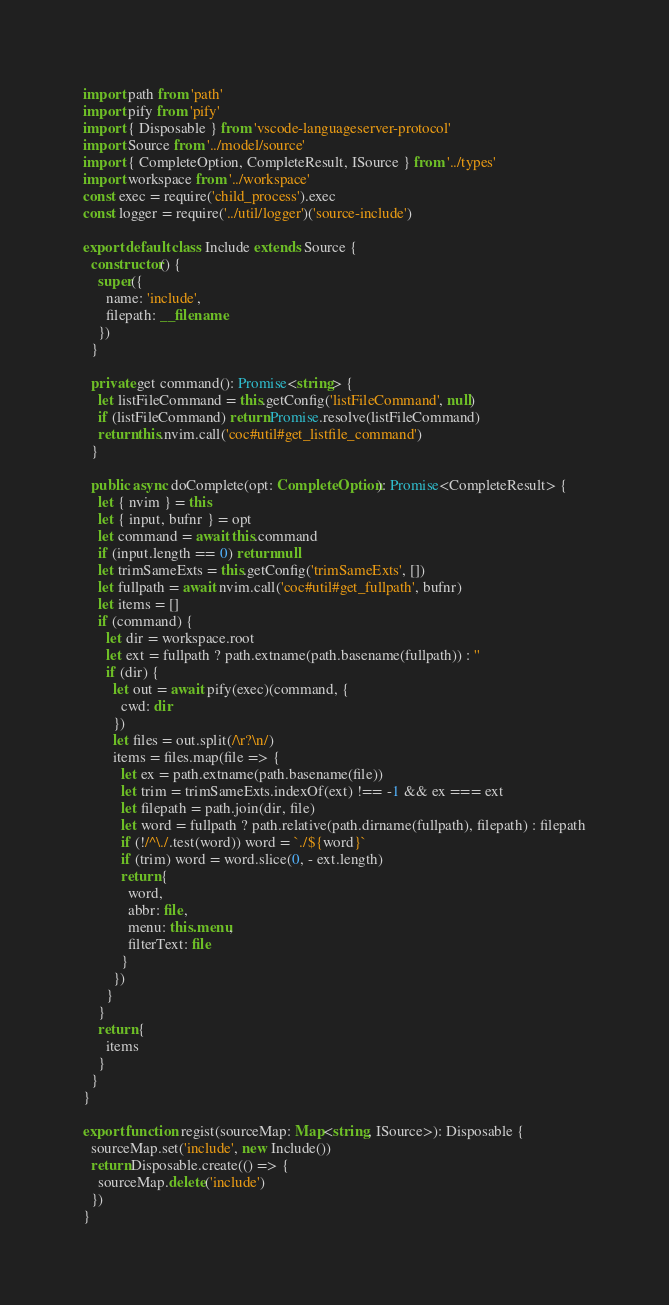Convert code to text. <code><loc_0><loc_0><loc_500><loc_500><_TypeScript_>import path from 'path'
import pify from 'pify'
import { Disposable } from 'vscode-languageserver-protocol'
import Source from '../model/source'
import { CompleteOption, CompleteResult, ISource } from '../types'
import workspace from '../workspace'
const exec = require('child_process').exec
const logger = require('../util/logger')('source-include')

export default class Include extends Source {
  constructor() {
    super({
      name: 'include',
      filepath: __filename
    })
  }

  private get command(): Promise<string> {
    let listFileCommand = this.getConfig('listFileCommand', null)
    if (listFileCommand) return Promise.resolve(listFileCommand)
    return this.nvim.call('coc#util#get_listfile_command')
  }

  public async doComplete(opt: CompleteOption): Promise<CompleteResult> {
    let { nvim } = this
    let { input, bufnr } = opt
    let command = await this.command
    if (input.length == 0) return null
    let trimSameExts = this.getConfig('trimSameExts', [])
    let fullpath = await nvim.call('coc#util#get_fullpath', bufnr)
    let items = []
    if (command) {
      let dir = workspace.root
      let ext = fullpath ? path.extname(path.basename(fullpath)) : ''
      if (dir) {
        let out = await pify(exec)(command, {
          cwd: dir
        })
        let files = out.split(/\r?\n/)
        items = files.map(file => {
          let ex = path.extname(path.basename(file))
          let trim = trimSameExts.indexOf(ext) !== -1 && ex === ext
          let filepath = path.join(dir, file)
          let word = fullpath ? path.relative(path.dirname(fullpath), filepath) : filepath
          if (!/^\./.test(word)) word = `./${word}`
          if (trim) word = word.slice(0, - ext.length)
          return {
            word,
            abbr: file,
            menu: this.menu,
            filterText: file
          }
        })
      }
    }
    return {
      items
    }
  }
}

export function regist(sourceMap: Map<string, ISource>): Disposable {
  sourceMap.set('include', new Include())
  return Disposable.create(() => {
    sourceMap.delete('include')
  })
}
</code> 